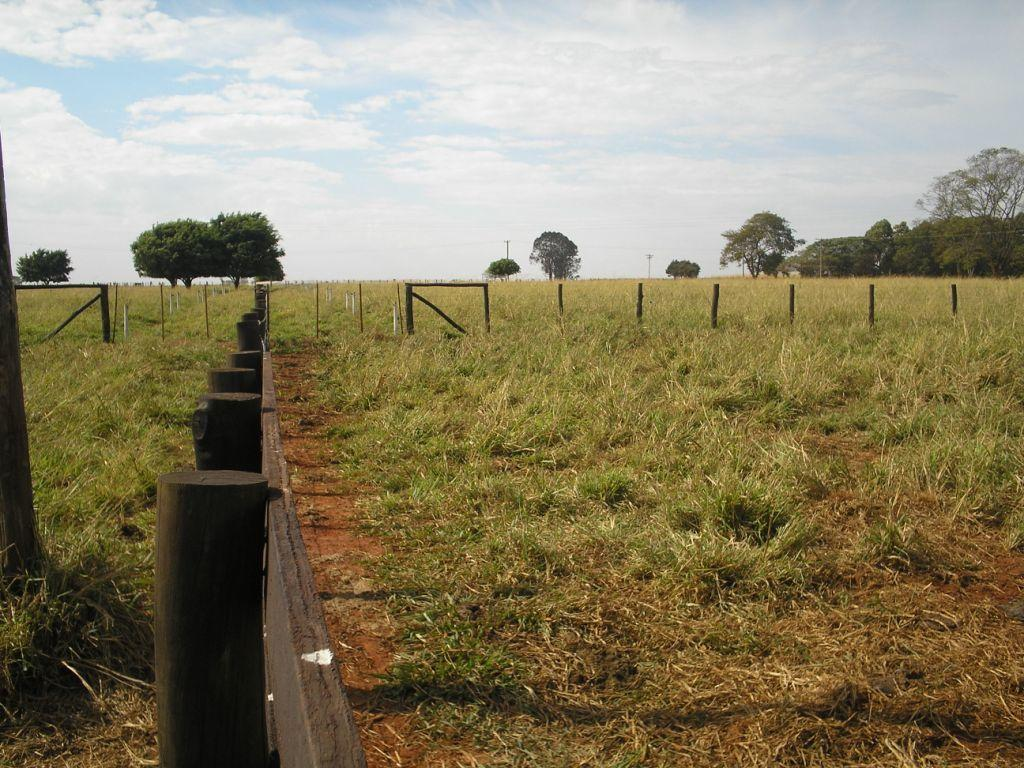What type of landscape is depicted in the image? The image contains grassland. What is present on the grassland? There is a fence on the grassland. What material is the fence made of on the left side? The fence is made of wood on the left side. What can be seen in the middle of the image? There are trees in the middle of the image. What is visible at the top of the image? The sky is visible at the top of the image. What can be observed in the sky? There are clouds in the sky. How many friends can be seen laughing in the tent in the image? There is no tent or friends present in the image; it features grassland, a fence, trees, and a sky with clouds. 